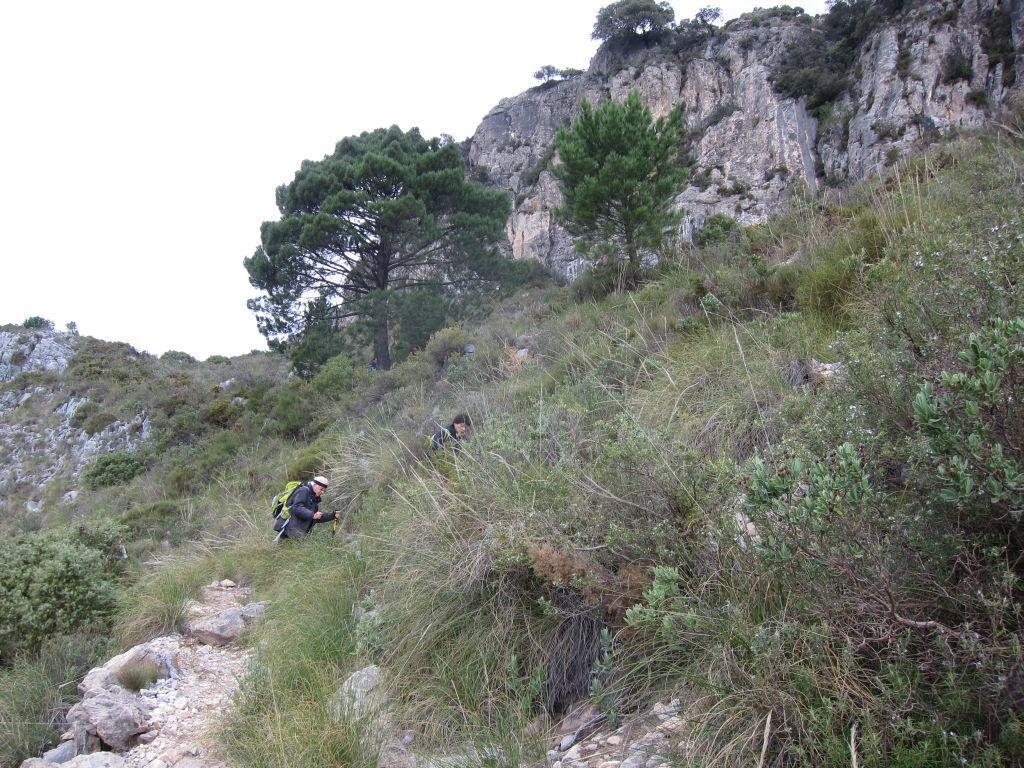How would you summarize this image in a sentence or two? In the image there is a hill and two people are walking on the hill, around them there is a lot of grass and trees. 